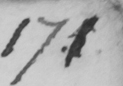Please transcribe the handwritten text in this image. 17 5 